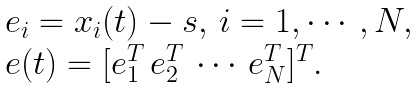Convert formula to latex. <formula><loc_0><loc_0><loc_500><loc_500>\begin{array} { l } e _ { i } = x _ { i } ( t ) - s , \, i = 1 , \cdots , N , \\ e ( t ) = [ e _ { 1 } ^ { T } \, e _ { 2 } ^ { T } \, \cdots \, e _ { N } ^ { T } ] ^ { T } . \end{array}</formula> 